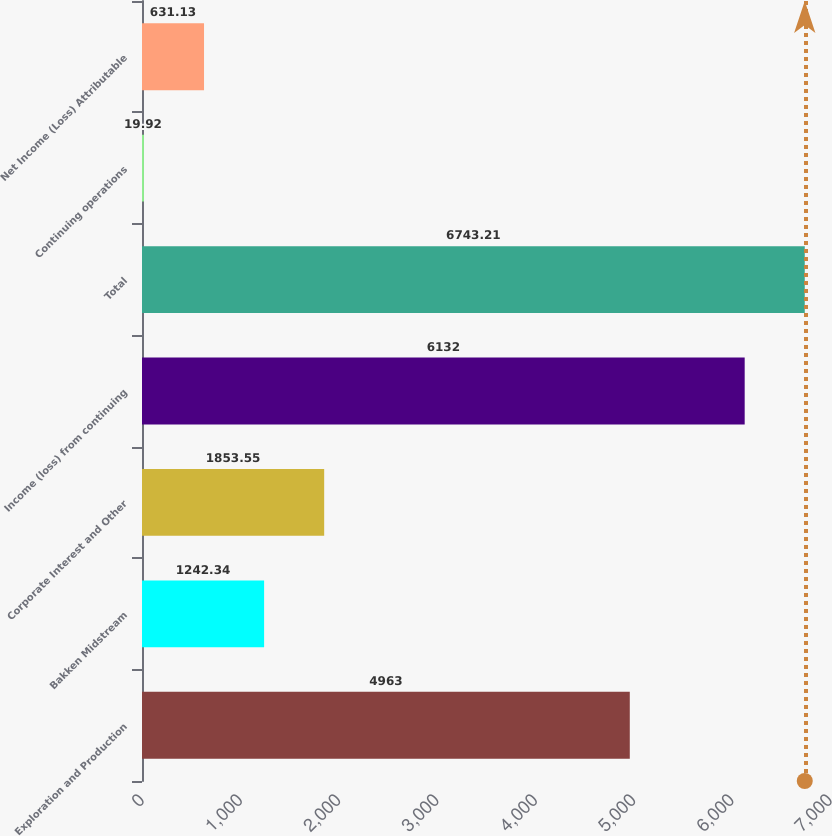Convert chart to OTSL. <chart><loc_0><loc_0><loc_500><loc_500><bar_chart><fcel>Exploration and Production<fcel>Bakken Midstream<fcel>Corporate Interest and Other<fcel>Income (loss) from continuing<fcel>Total<fcel>Continuing operations<fcel>Net Income (Loss) Attributable<nl><fcel>4963<fcel>1242.34<fcel>1853.55<fcel>6132<fcel>6743.21<fcel>19.92<fcel>631.13<nl></chart> 